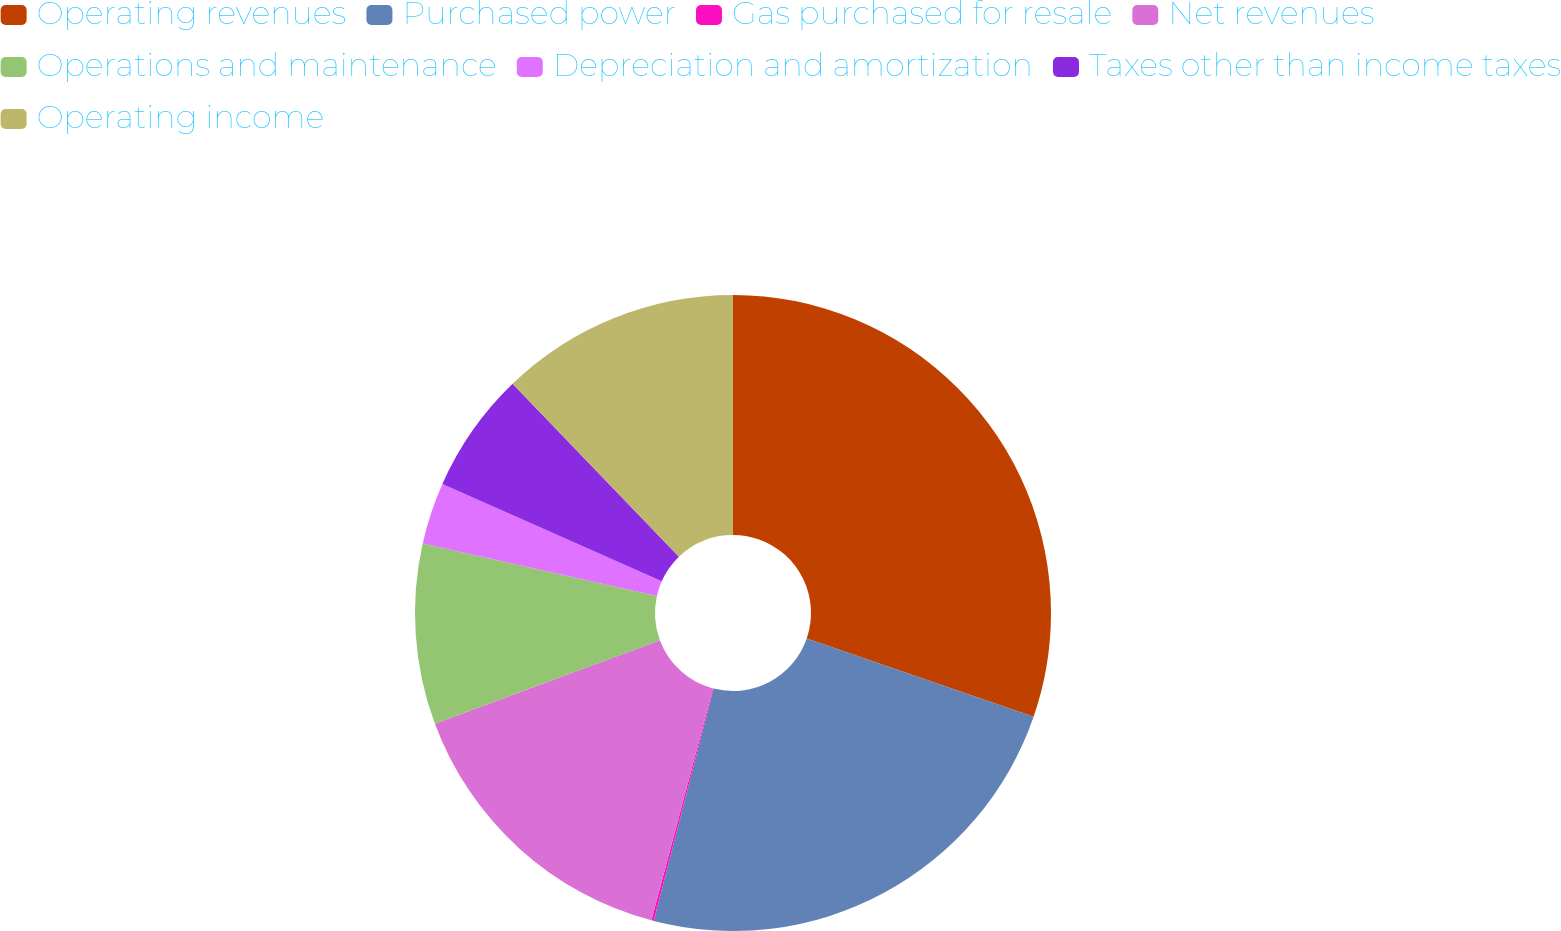Convert chart to OTSL. <chart><loc_0><loc_0><loc_500><loc_500><pie_chart><fcel>Operating revenues<fcel>Purchased power<fcel>Gas purchased for resale<fcel>Net revenues<fcel>Operations and maintenance<fcel>Depreciation and amortization<fcel>Taxes other than income taxes<fcel>Operating income<nl><fcel>30.29%<fcel>23.72%<fcel>0.12%<fcel>15.21%<fcel>9.17%<fcel>3.14%<fcel>6.16%<fcel>12.19%<nl></chart> 